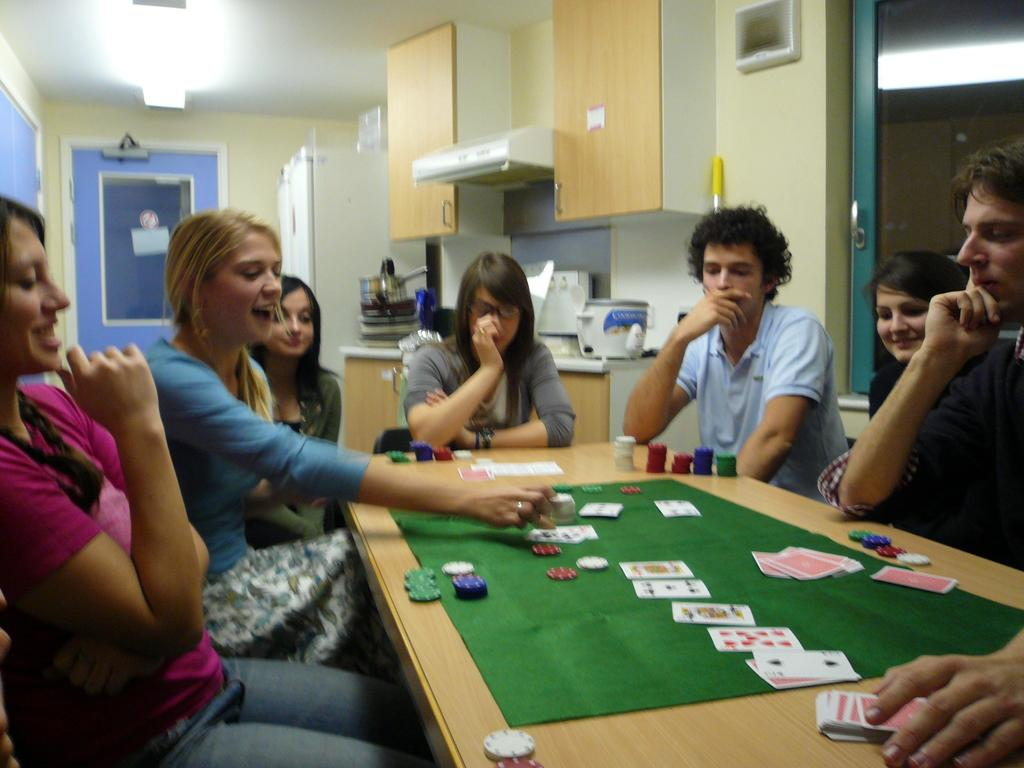How many people are sitting at the table in the image? There are many people sitting at the table in the image. What are the people doing at the table? The people are playing cards. What is on the table that the people are sitting at? There is a green mat on the table. What else can be seen on the table besides the green mat? Coins are visible on the table. What can be seen in the background of the image? In the background, there is a wall, a cupboard, and a cooker. What type of liquid is being poured from the clover in the image? There is no clover or liquid present in the image. What is the size of the hall where the people are playing cards? The image does not show a hall, only a table with people playing cards, so it is not possible to determine the size of a hall. 